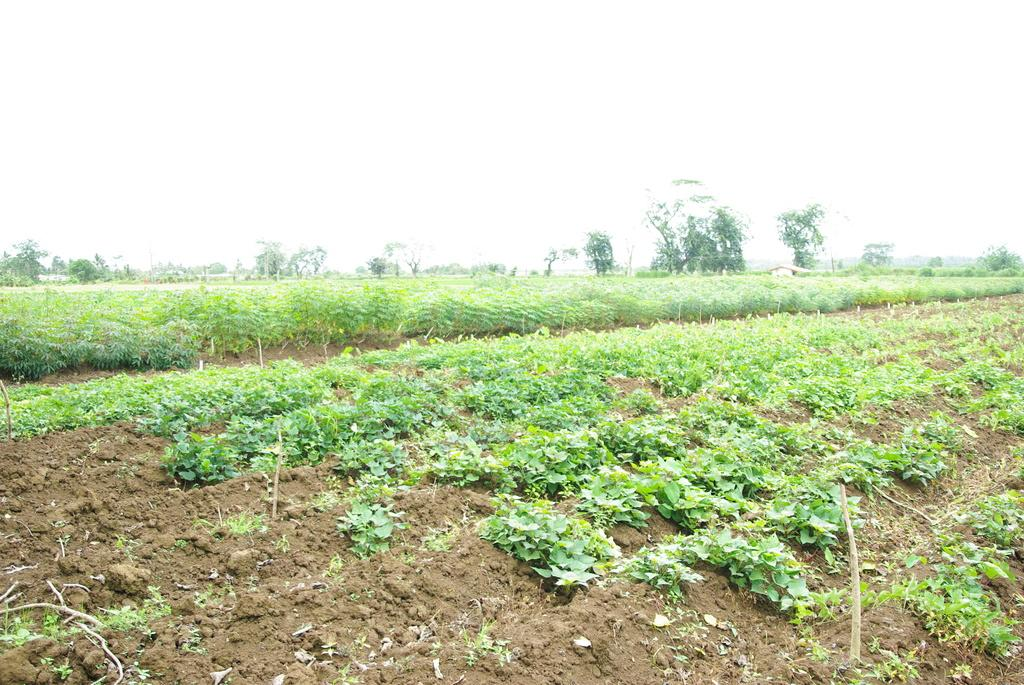What type of vegetation can be seen in the image? There are trees and plants in the image. What type of structure is visible in the image? There is a house in the image. What is visible at the top of the image? The sky is visible at the top of the image. What is present at the bottom of the image? Mud is present at the bottom of the image. What type of feast is being prepared in the image? There is no indication of a feast or any food preparation in the image. How many soldiers are present in the image? There are no soldiers or army-related elements present in the image. 